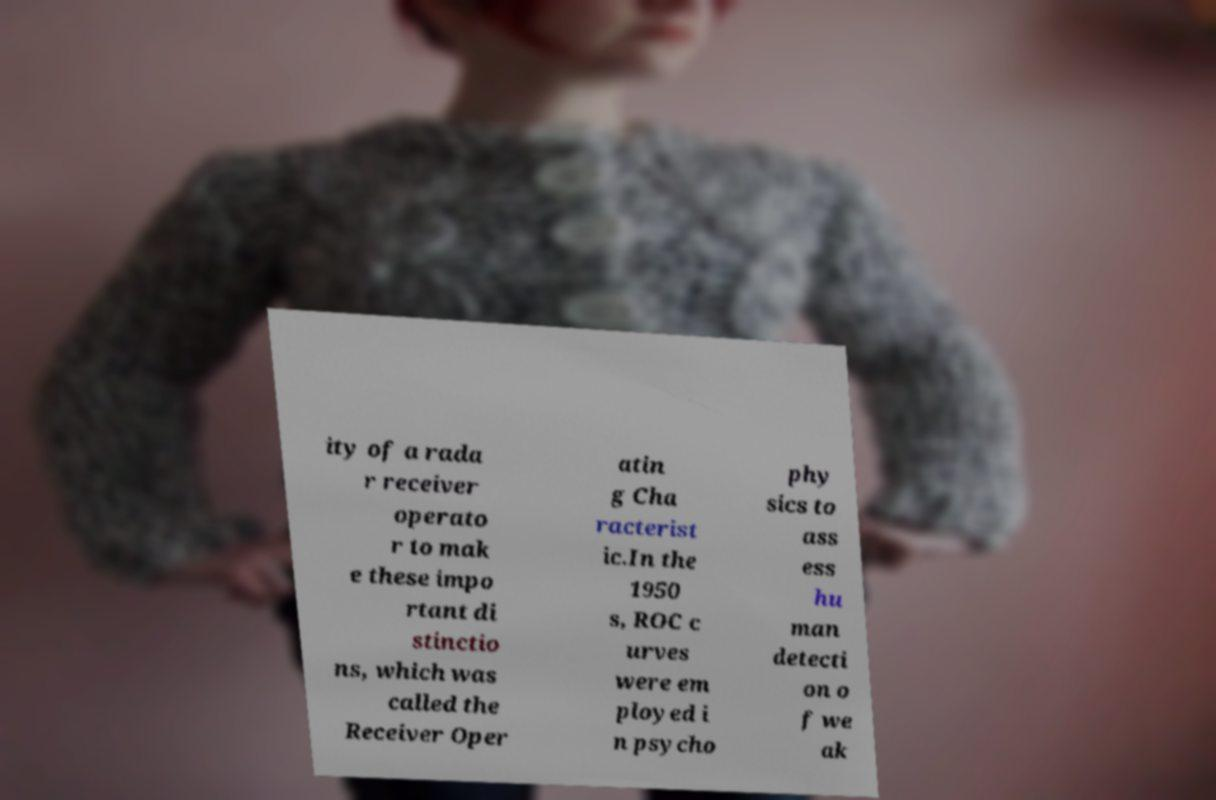What messages or text are displayed in this image? I need them in a readable, typed format. ity of a rada r receiver operato r to mak e these impo rtant di stinctio ns, which was called the Receiver Oper atin g Cha racterist ic.In the 1950 s, ROC c urves were em ployed i n psycho phy sics to ass ess hu man detecti on o f we ak 